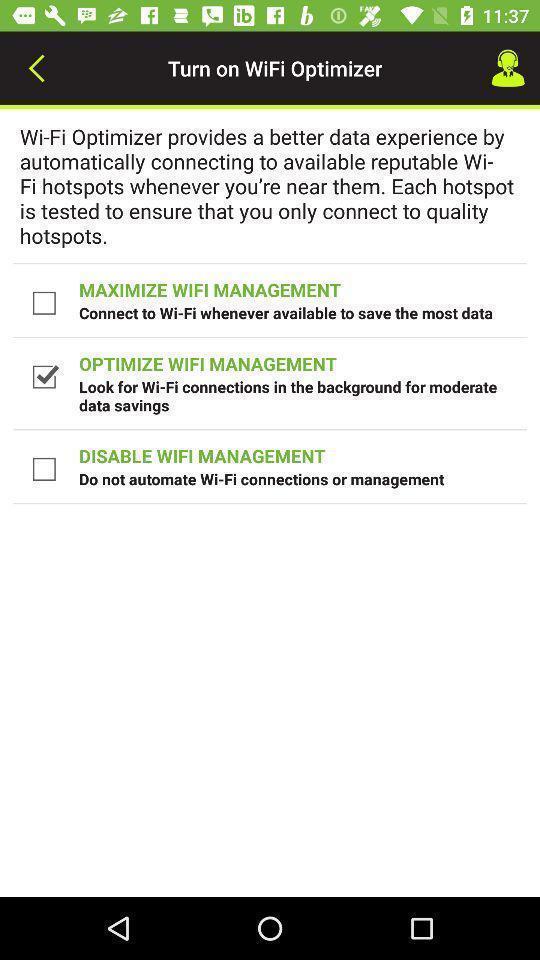Provide a description of this screenshot. Page showing different options. 